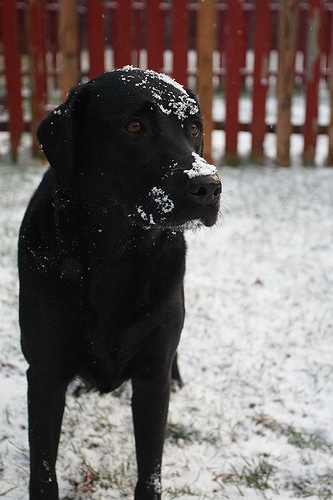<image>
Can you confirm if the dog is to the left of the snow? No. The dog is not to the left of the snow. From this viewpoint, they have a different horizontal relationship. 